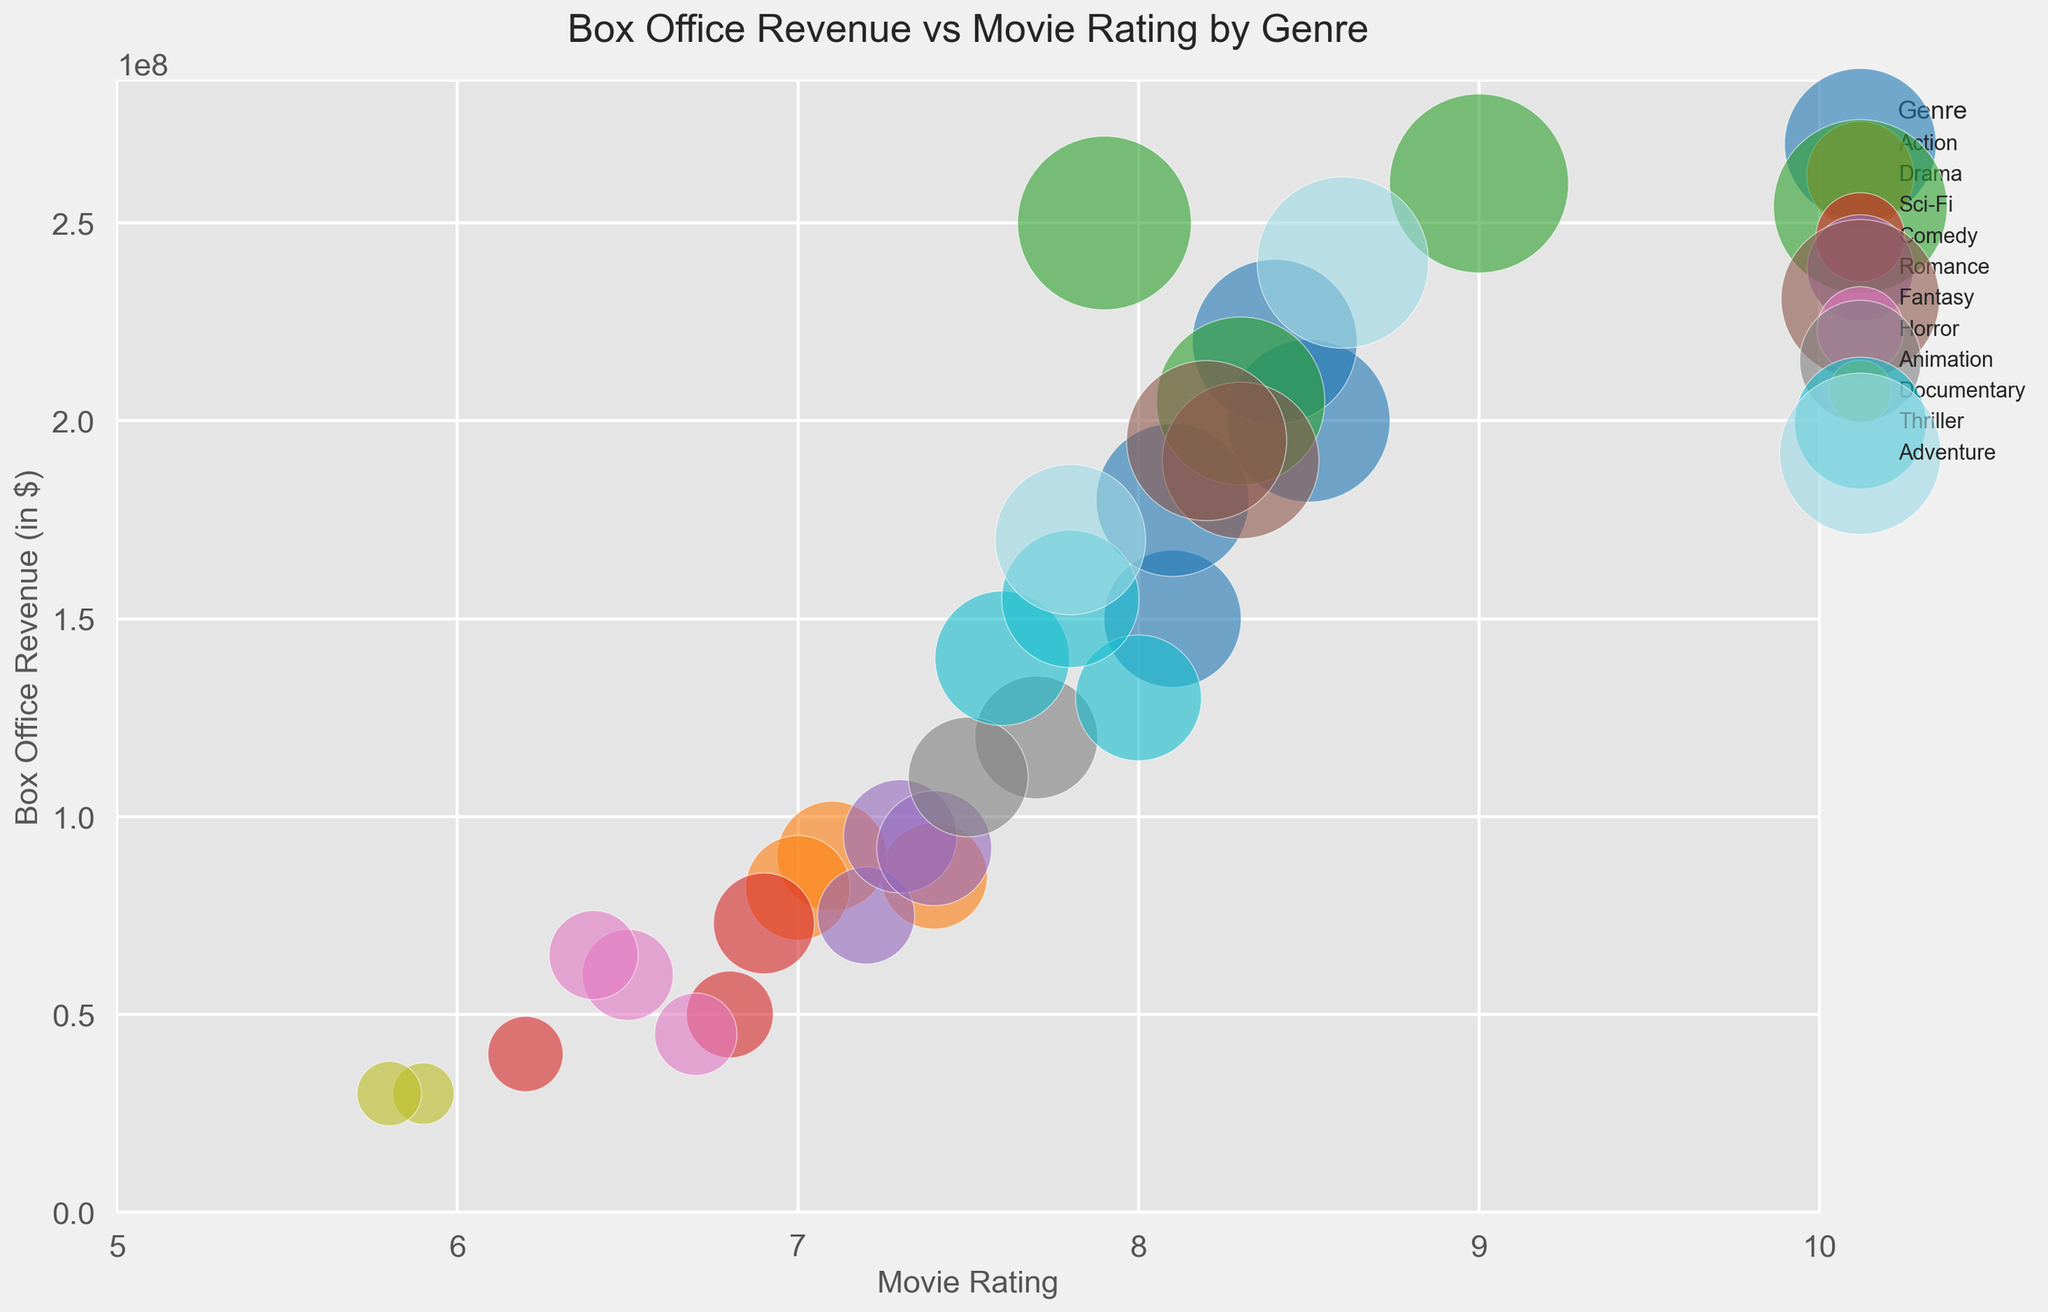Which genre has the highest box office revenue? By looking at the scatter plot, observe which genre's bubble appears the highest on the y-axis, representing the box office revenue.
Answer: Sci-Fi Which genre has the most movies with a rating above 8.0? Count the number of bubbles in each genre that have their x-axis (movie rating) value higher than 8.0.
Answer: Action What is the average box office revenue for Action movies with a rating above 8.0? Identify the Action movies that have a rating above 8.0: Movie5 ($200M), Movie14 ($220M), Movie25 ($180M). Sum their revenues and divide by the number of movies: (200 + 220 + 180) / 3.
Answer: $200M Which genre has the largest bubble based on audience size? Locate the largest bubble in the plot and check the legend for its corresponding genre.
Answer: Sci-Fi Comparing the highest box office revenue in Action and Drama, which one is higher? Identify the highest points on the y-axis for both genres and compare them. Action's highest is $220M and Drama's highest is $90M.
Answer: Action Which movie has the lowest rating, and what is its genre? Find the bubble that is farthest left on the x-axis, then refer to its color or look it up in the genre legend.
Answer: Documentary Do Thrillers or Dramas generally have higher box office revenues? Compare the vertical spread (y-axis) of the Thrillers to Dramas, by visually assessing which genre's bubbles appear higher on average.
Answer: Thrillers What is the difference in box office revenue between the highest-rated Sci-Fi and Action movies? Identify the highest-rated movie in Sci-Fi (Movie16, $260M) and Action (Movie14, $220M), then calculate the difference: $260M - $220M.
Answer: $40M Which genres have movies represented within the 6.0 to 6.5 rating range? Look for bubbles placed between 6.0 and 6.5 on the x-axis and check their corresponding genres on the plot.
Answer: Comedy, Horror, Documentary 